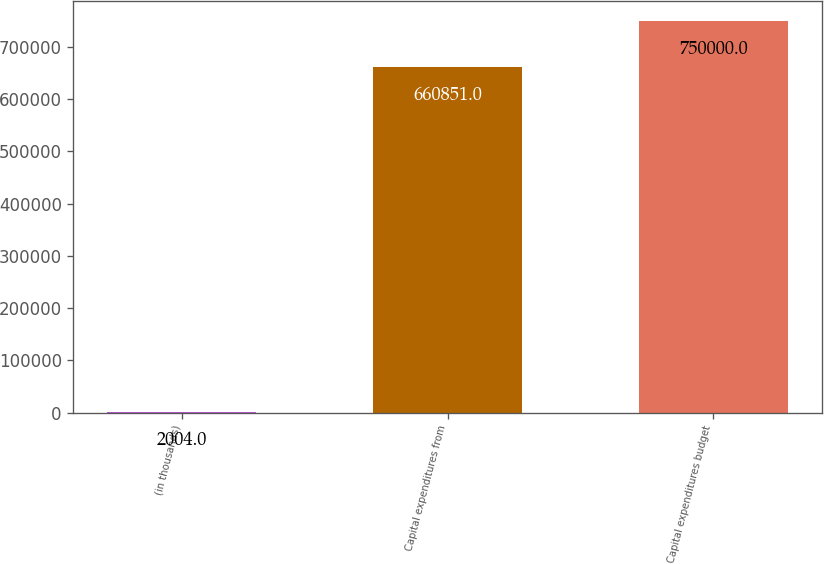<chart> <loc_0><loc_0><loc_500><loc_500><bar_chart><fcel>(in thousands)<fcel>Capital expenditures from<fcel>Capital expenditures budget<nl><fcel>2004<fcel>660851<fcel>750000<nl></chart> 